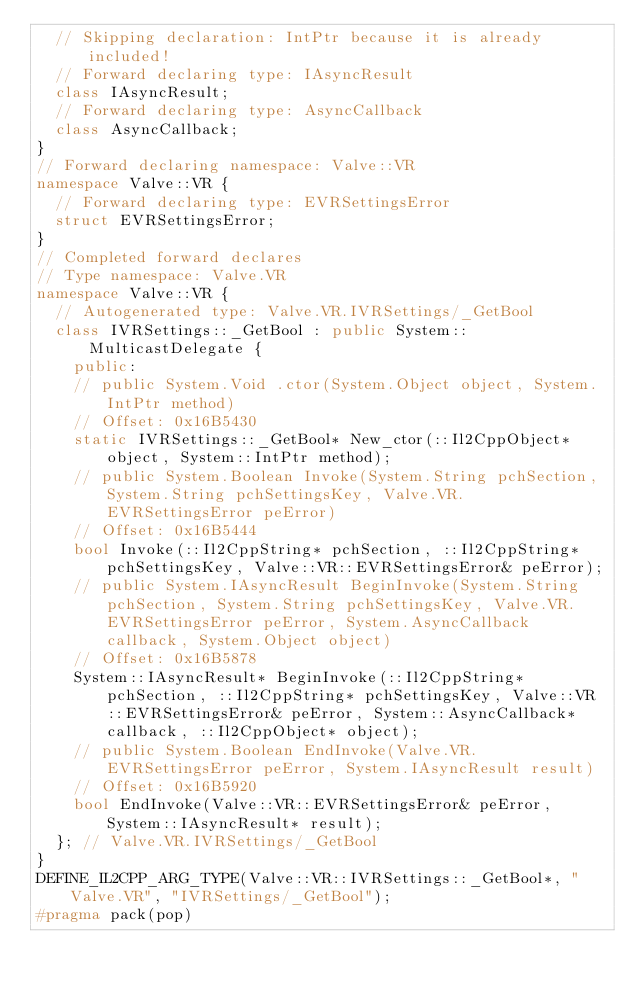Convert code to text. <code><loc_0><loc_0><loc_500><loc_500><_C++_>  // Skipping declaration: IntPtr because it is already included!
  // Forward declaring type: IAsyncResult
  class IAsyncResult;
  // Forward declaring type: AsyncCallback
  class AsyncCallback;
}
// Forward declaring namespace: Valve::VR
namespace Valve::VR {
  // Forward declaring type: EVRSettingsError
  struct EVRSettingsError;
}
// Completed forward declares
// Type namespace: Valve.VR
namespace Valve::VR {
  // Autogenerated type: Valve.VR.IVRSettings/_GetBool
  class IVRSettings::_GetBool : public System::MulticastDelegate {
    public:
    // public System.Void .ctor(System.Object object, System.IntPtr method)
    // Offset: 0x16B5430
    static IVRSettings::_GetBool* New_ctor(::Il2CppObject* object, System::IntPtr method);
    // public System.Boolean Invoke(System.String pchSection, System.String pchSettingsKey, Valve.VR.EVRSettingsError peError)
    // Offset: 0x16B5444
    bool Invoke(::Il2CppString* pchSection, ::Il2CppString* pchSettingsKey, Valve::VR::EVRSettingsError& peError);
    // public System.IAsyncResult BeginInvoke(System.String pchSection, System.String pchSettingsKey, Valve.VR.EVRSettingsError peError, System.AsyncCallback callback, System.Object object)
    // Offset: 0x16B5878
    System::IAsyncResult* BeginInvoke(::Il2CppString* pchSection, ::Il2CppString* pchSettingsKey, Valve::VR::EVRSettingsError& peError, System::AsyncCallback* callback, ::Il2CppObject* object);
    // public System.Boolean EndInvoke(Valve.VR.EVRSettingsError peError, System.IAsyncResult result)
    // Offset: 0x16B5920
    bool EndInvoke(Valve::VR::EVRSettingsError& peError, System::IAsyncResult* result);
  }; // Valve.VR.IVRSettings/_GetBool
}
DEFINE_IL2CPP_ARG_TYPE(Valve::VR::IVRSettings::_GetBool*, "Valve.VR", "IVRSettings/_GetBool");
#pragma pack(pop)
</code> 